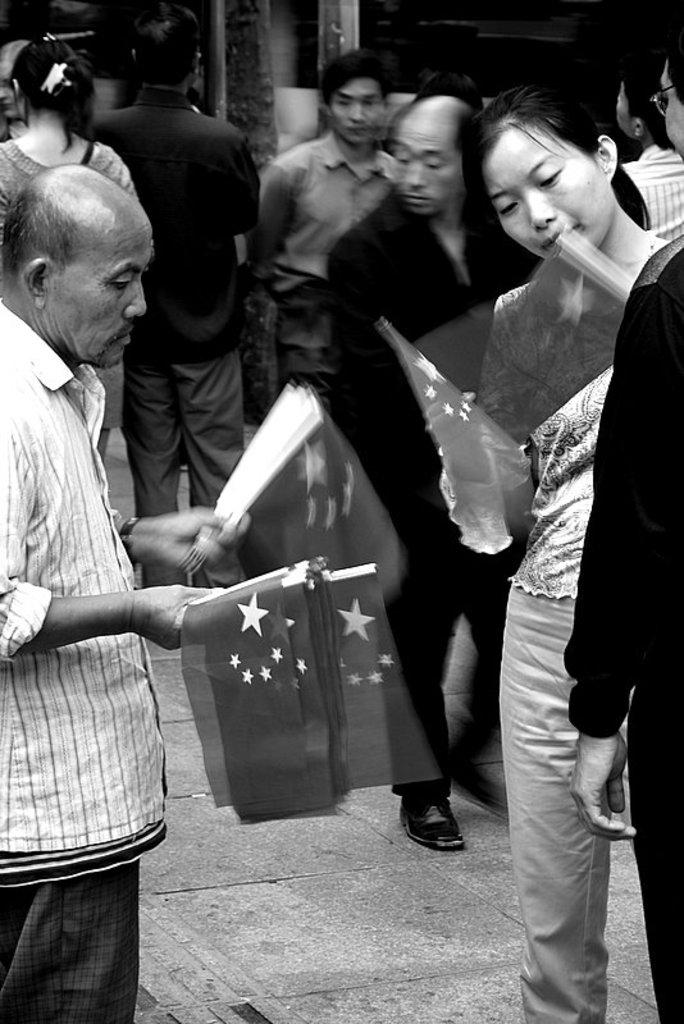What is the main subject of the image? There is a person in the image. What is the person doing in the image? The person is holding some things. Are there any other people in the image? Yes, there are other people in the image. What type of toothpaste is being used by the person in the image? There is no toothpaste present in the image. 